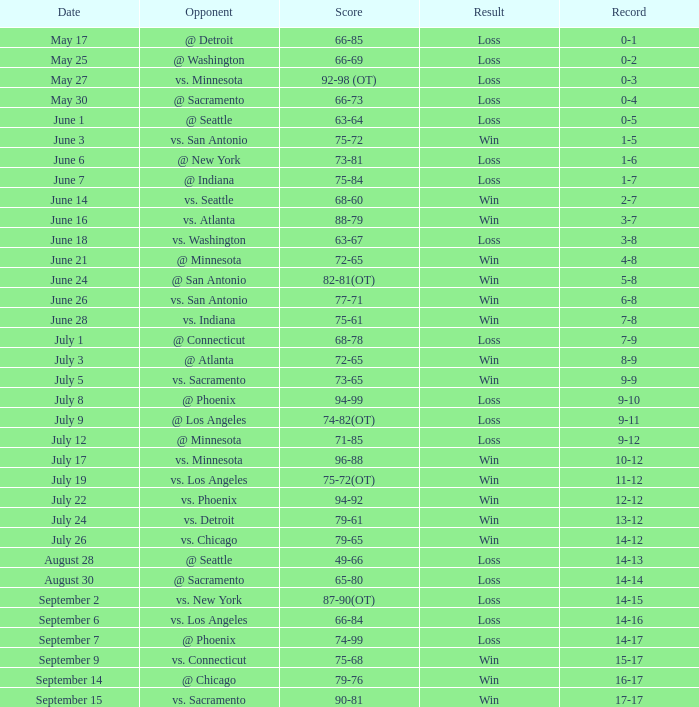Can you parse all the data within this table? {'header': ['Date', 'Opponent', 'Score', 'Result', 'Record'], 'rows': [['May 17', '@ Detroit', '66-85', 'Loss', '0-1'], ['May 25', '@ Washington', '66-69', 'Loss', '0-2'], ['May 27', 'vs. Minnesota', '92-98 (OT)', 'Loss', '0-3'], ['May 30', '@ Sacramento', '66-73', 'Loss', '0-4'], ['June 1', '@ Seattle', '63-64', 'Loss', '0-5'], ['June 3', 'vs. San Antonio', '75-72', 'Win', '1-5'], ['June 6', '@ New York', '73-81', 'Loss', '1-6'], ['June 7', '@ Indiana', '75-84', 'Loss', '1-7'], ['June 14', 'vs. Seattle', '68-60', 'Win', '2-7'], ['June 16', 'vs. Atlanta', '88-79', 'Win', '3-7'], ['June 18', 'vs. Washington', '63-67', 'Loss', '3-8'], ['June 21', '@ Minnesota', '72-65', 'Win', '4-8'], ['June 24', '@ San Antonio', '82-81(OT)', 'Win', '5-8'], ['June 26', 'vs. San Antonio', '77-71', 'Win', '6-8'], ['June 28', 'vs. Indiana', '75-61', 'Win', '7-8'], ['July 1', '@ Connecticut', '68-78', 'Loss', '7-9'], ['July 3', '@ Atlanta', '72-65', 'Win', '8-9'], ['July 5', 'vs. Sacramento', '73-65', 'Win', '9-9'], ['July 8', '@ Phoenix', '94-99', 'Loss', '9-10'], ['July 9', '@ Los Angeles', '74-82(OT)', 'Loss', '9-11'], ['July 12', '@ Minnesota', '71-85', 'Loss', '9-12'], ['July 17', 'vs. Minnesota', '96-88', 'Win', '10-12'], ['July 19', 'vs. Los Angeles', '75-72(OT)', 'Win', '11-12'], ['July 22', 'vs. Phoenix', '94-92', 'Win', '12-12'], ['July 24', 'vs. Detroit', '79-61', 'Win', '13-12'], ['July 26', 'vs. Chicago', '79-65', 'Win', '14-12'], ['August 28', '@ Seattle', '49-66', 'Loss', '14-13'], ['August 30', '@ Sacramento', '65-80', 'Loss', '14-14'], ['September 2', 'vs. New York', '87-90(OT)', 'Loss', '14-15'], ['September 6', 'vs. Los Angeles', '66-84', 'Loss', '14-16'], ['September 7', '@ Phoenix', '74-99', 'Loss', '14-17'], ['September 9', 'vs. Connecticut', '75-68', 'Win', '15-17'], ['September 14', '@ Chicago', '79-76', 'Win', '16-17'], ['September 15', 'vs. Sacramento', '90-81', 'Win', '17-17']]} What is the entry on july 12? 9-12. 